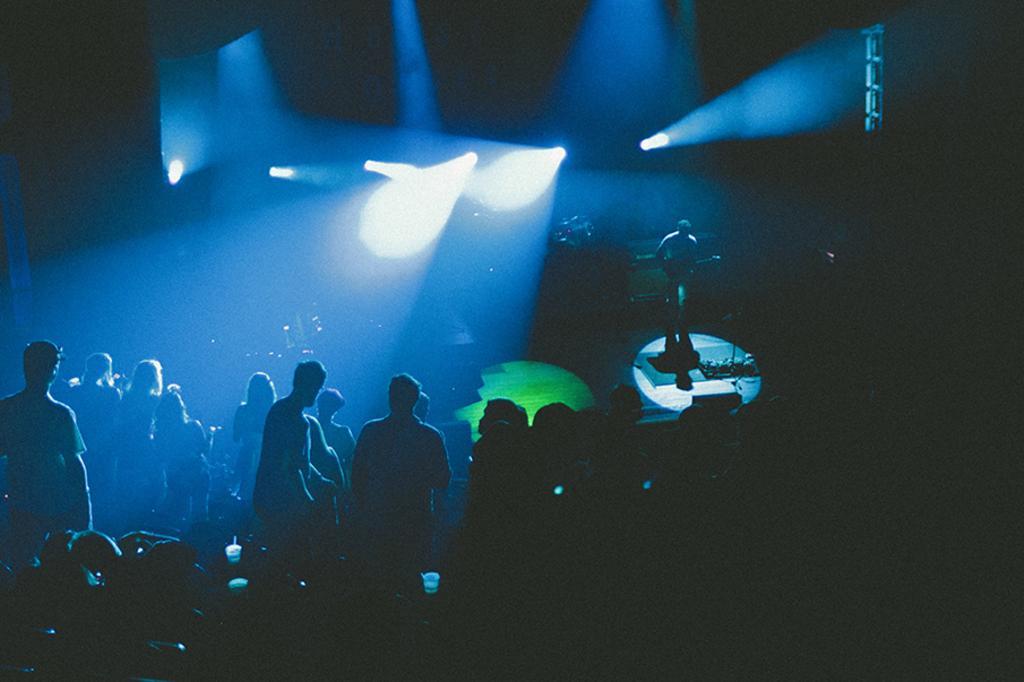How would you summarize this image in a sentence or two? In this image we can see there are so many people standing together in front of the stage where we can see there is a person playing guitar. 